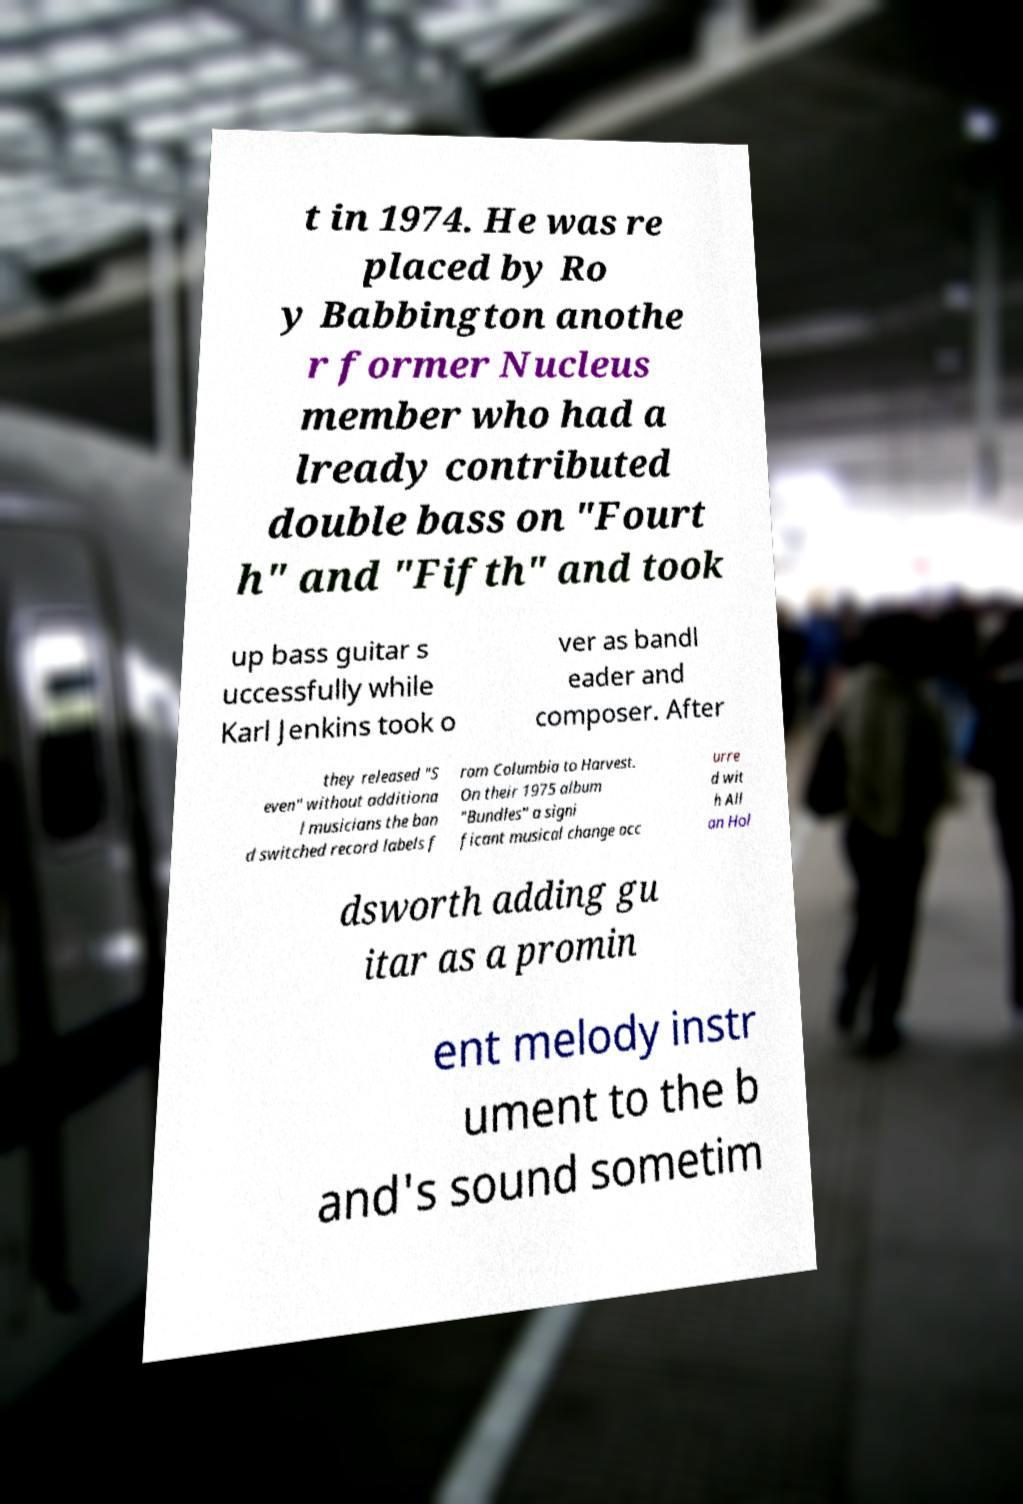For documentation purposes, I need the text within this image transcribed. Could you provide that? t in 1974. He was re placed by Ro y Babbington anothe r former Nucleus member who had a lready contributed double bass on "Fourt h" and "Fifth" and took up bass guitar s uccessfully while Karl Jenkins took o ver as bandl eader and composer. After they released "S even" without additiona l musicians the ban d switched record labels f rom Columbia to Harvest. On their 1975 album "Bundles" a signi ficant musical change occ urre d wit h All an Hol dsworth adding gu itar as a promin ent melody instr ument to the b and's sound sometim 